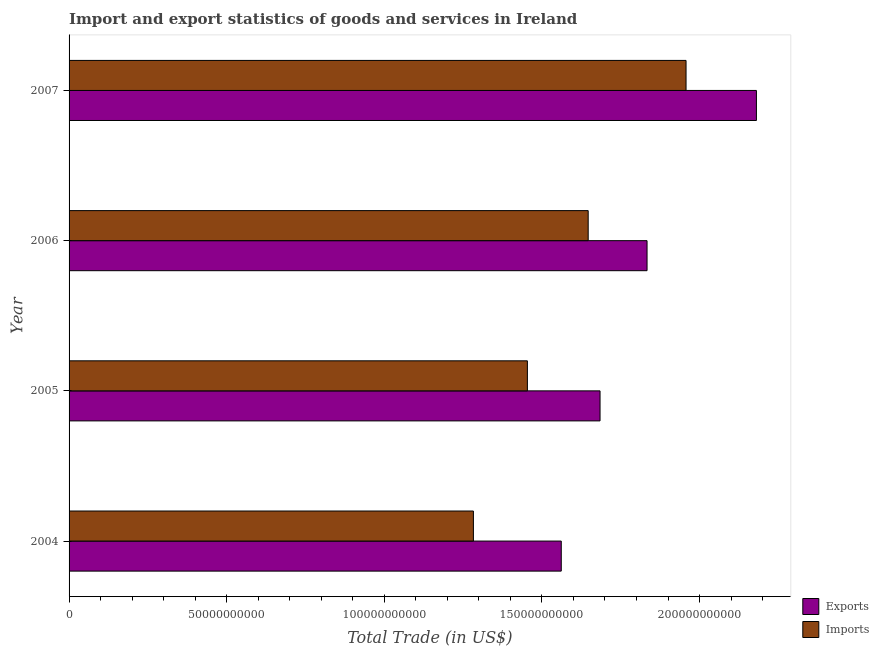How many different coloured bars are there?
Provide a short and direct response. 2. How many groups of bars are there?
Your answer should be compact. 4. Are the number of bars per tick equal to the number of legend labels?
Offer a very short reply. Yes. How many bars are there on the 1st tick from the top?
Offer a very short reply. 2. How many bars are there on the 4th tick from the bottom?
Ensure brevity in your answer.  2. In how many cases, is the number of bars for a given year not equal to the number of legend labels?
Offer a terse response. 0. What is the imports of goods and services in 2005?
Offer a terse response. 1.45e+11. Across all years, what is the maximum export of goods and services?
Offer a very short reply. 2.18e+11. Across all years, what is the minimum imports of goods and services?
Your response must be concise. 1.28e+11. In which year was the export of goods and services maximum?
Provide a succinct answer. 2007. In which year was the imports of goods and services minimum?
Offer a very short reply. 2004. What is the total imports of goods and services in the graph?
Provide a short and direct response. 6.34e+11. What is the difference between the export of goods and services in 2004 and that in 2007?
Make the answer very short. -6.19e+1. What is the difference between the imports of goods and services in 2007 and the export of goods and services in 2004?
Offer a very short reply. 3.96e+1. What is the average export of goods and services per year?
Make the answer very short. 1.81e+11. In the year 2006, what is the difference between the export of goods and services and imports of goods and services?
Your response must be concise. 1.87e+1. In how many years, is the export of goods and services greater than 40000000000 US$?
Provide a succinct answer. 4. What is the ratio of the export of goods and services in 2004 to that in 2006?
Your answer should be compact. 0.85. What is the difference between the highest and the second highest export of goods and services?
Give a very brief answer. 3.47e+1. What is the difference between the highest and the lowest export of goods and services?
Your answer should be very brief. 6.19e+1. In how many years, is the imports of goods and services greater than the average imports of goods and services taken over all years?
Offer a very short reply. 2. Is the sum of the imports of goods and services in 2006 and 2007 greater than the maximum export of goods and services across all years?
Give a very brief answer. Yes. What does the 1st bar from the top in 2006 represents?
Keep it short and to the point. Imports. What does the 1st bar from the bottom in 2007 represents?
Ensure brevity in your answer.  Exports. How many bars are there?
Offer a terse response. 8. Are all the bars in the graph horizontal?
Make the answer very short. Yes. How many years are there in the graph?
Offer a terse response. 4. Are the values on the major ticks of X-axis written in scientific E-notation?
Keep it short and to the point. No. Does the graph contain any zero values?
Keep it short and to the point. No. How are the legend labels stacked?
Offer a very short reply. Vertical. What is the title of the graph?
Make the answer very short. Import and export statistics of goods and services in Ireland. What is the label or title of the X-axis?
Your answer should be very brief. Total Trade (in US$). What is the label or title of the Y-axis?
Offer a very short reply. Year. What is the Total Trade (in US$) in Exports in 2004?
Offer a terse response. 1.56e+11. What is the Total Trade (in US$) in Imports in 2004?
Offer a terse response. 1.28e+11. What is the Total Trade (in US$) in Exports in 2005?
Make the answer very short. 1.68e+11. What is the Total Trade (in US$) in Imports in 2005?
Make the answer very short. 1.45e+11. What is the Total Trade (in US$) in Exports in 2006?
Keep it short and to the point. 1.83e+11. What is the Total Trade (in US$) of Imports in 2006?
Ensure brevity in your answer.  1.65e+11. What is the Total Trade (in US$) of Exports in 2007?
Your answer should be compact. 2.18e+11. What is the Total Trade (in US$) of Imports in 2007?
Provide a succinct answer. 1.96e+11. Across all years, what is the maximum Total Trade (in US$) in Exports?
Make the answer very short. 2.18e+11. Across all years, what is the maximum Total Trade (in US$) of Imports?
Your answer should be very brief. 1.96e+11. Across all years, what is the minimum Total Trade (in US$) of Exports?
Provide a succinct answer. 1.56e+11. Across all years, what is the minimum Total Trade (in US$) in Imports?
Keep it short and to the point. 1.28e+11. What is the total Total Trade (in US$) of Exports in the graph?
Your answer should be compact. 7.26e+11. What is the total Total Trade (in US$) in Imports in the graph?
Your response must be concise. 6.34e+11. What is the difference between the Total Trade (in US$) of Exports in 2004 and that in 2005?
Your response must be concise. -1.23e+1. What is the difference between the Total Trade (in US$) of Imports in 2004 and that in 2005?
Offer a very short reply. -1.71e+1. What is the difference between the Total Trade (in US$) in Exports in 2004 and that in 2006?
Offer a terse response. -2.72e+1. What is the difference between the Total Trade (in US$) in Imports in 2004 and that in 2006?
Provide a short and direct response. -3.64e+1. What is the difference between the Total Trade (in US$) of Exports in 2004 and that in 2007?
Keep it short and to the point. -6.19e+1. What is the difference between the Total Trade (in US$) in Imports in 2004 and that in 2007?
Your answer should be compact. -6.75e+1. What is the difference between the Total Trade (in US$) of Exports in 2005 and that in 2006?
Provide a short and direct response. -1.49e+1. What is the difference between the Total Trade (in US$) in Imports in 2005 and that in 2006?
Your answer should be compact. -1.93e+1. What is the difference between the Total Trade (in US$) in Exports in 2005 and that in 2007?
Offer a terse response. -4.96e+1. What is the difference between the Total Trade (in US$) in Imports in 2005 and that in 2007?
Offer a terse response. -5.03e+1. What is the difference between the Total Trade (in US$) of Exports in 2006 and that in 2007?
Your answer should be very brief. -3.47e+1. What is the difference between the Total Trade (in US$) in Imports in 2006 and that in 2007?
Your answer should be very brief. -3.10e+1. What is the difference between the Total Trade (in US$) in Exports in 2004 and the Total Trade (in US$) in Imports in 2005?
Provide a short and direct response. 1.07e+1. What is the difference between the Total Trade (in US$) of Exports in 2004 and the Total Trade (in US$) of Imports in 2006?
Your response must be concise. -8.54e+09. What is the difference between the Total Trade (in US$) in Exports in 2004 and the Total Trade (in US$) in Imports in 2007?
Give a very brief answer. -3.96e+1. What is the difference between the Total Trade (in US$) in Exports in 2005 and the Total Trade (in US$) in Imports in 2006?
Provide a short and direct response. 3.76e+09. What is the difference between the Total Trade (in US$) of Exports in 2005 and the Total Trade (in US$) of Imports in 2007?
Your answer should be compact. -2.73e+1. What is the difference between the Total Trade (in US$) in Exports in 2006 and the Total Trade (in US$) in Imports in 2007?
Make the answer very short. -1.24e+1. What is the average Total Trade (in US$) of Exports per year?
Provide a succinct answer. 1.81e+11. What is the average Total Trade (in US$) in Imports per year?
Keep it short and to the point. 1.59e+11. In the year 2004, what is the difference between the Total Trade (in US$) in Exports and Total Trade (in US$) in Imports?
Your response must be concise. 2.79e+1. In the year 2005, what is the difference between the Total Trade (in US$) of Exports and Total Trade (in US$) of Imports?
Keep it short and to the point. 2.30e+1. In the year 2006, what is the difference between the Total Trade (in US$) in Exports and Total Trade (in US$) in Imports?
Provide a short and direct response. 1.87e+1. In the year 2007, what is the difference between the Total Trade (in US$) in Exports and Total Trade (in US$) in Imports?
Your response must be concise. 2.23e+1. What is the ratio of the Total Trade (in US$) of Exports in 2004 to that in 2005?
Give a very brief answer. 0.93. What is the ratio of the Total Trade (in US$) in Imports in 2004 to that in 2005?
Your answer should be very brief. 0.88. What is the ratio of the Total Trade (in US$) in Exports in 2004 to that in 2006?
Ensure brevity in your answer.  0.85. What is the ratio of the Total Trade (in US$) of Imports in 2004 to that in 2006?
Give a very brief answer. 0.78. What is the ratio of the Total Trade (in US$) in Exports in 2004 to that in 2007?
Provide a short and direct response. 0.72. What is the ratio of the Total Trade (in US$) in Imports in 2004 to that in 2007?
Provide a succinct answer. 0.66. What is the ratio of the Total Trade (in US$) of Exports in 2005 to that in 2006?
Keep it short and to the point. 0.92. What is the ratio of the Total Trade (in US$) of Imports in 2005 to that in 2006?
Keep it short and to the point. 0.88. What is the ratio of the Total Trade (in US$) in Exports in 2005 to that in 2007?
Provide a succinct answer. 0.77. What is the ratio of the Total Trade (in US$) in Imports in 2005 to that in 2007?
Offer a terse response. 0.74. What is the ratio of the Total Trade (in US$) in Exports in 2006 to that in 2007?
Give a very brief answer. 0.84. What is the ratio of the Total Trade (in US$) of Imports in 2006 to that in 2007?
Your response must be concise. 0.84. What is the difference between the highest and the second highest Total Trade (in US$) of Exports?
Your answer should be compact. 3.47e+1. What is the difference between the highest and the second highest Total Trade (in US$) of Imports?
Offer a very short reply. 3.10e+1. What is the difference between the highest and the lowest Total Trade (in US$) of Exports?
Your answer should be compact. 6.19e+1. What is the difference between the highest and the lowest Total Trade (in US$) in Imports?
Give a very brief answer. 6.75e+1. 